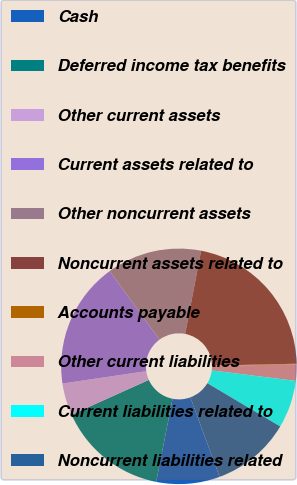Convert chart. <chart><loc_0><loc_0><loc_500><loc_500><pie_chart><fcel>Cash<fcel>Deferred income tax benefits<fcel>Other current assets<fcel>Current assets related to<fcel>Other noncurrent assets<fcel>Noncurrent assets related to<fcel>Accounts payable<fcel>Other current liabilities<fcel>Current liabilities related to<fcel>Noncurrent liabilities related<nl><fcel>8.71%<fcel>15.17%<fcel>4.4%<fcel>17.32%<fcel>13.02%<fcel>21.63%<fcel>0.09%<fcel>2.24%<fcel>6.55%<fcel>10.86%<nl></chart> 